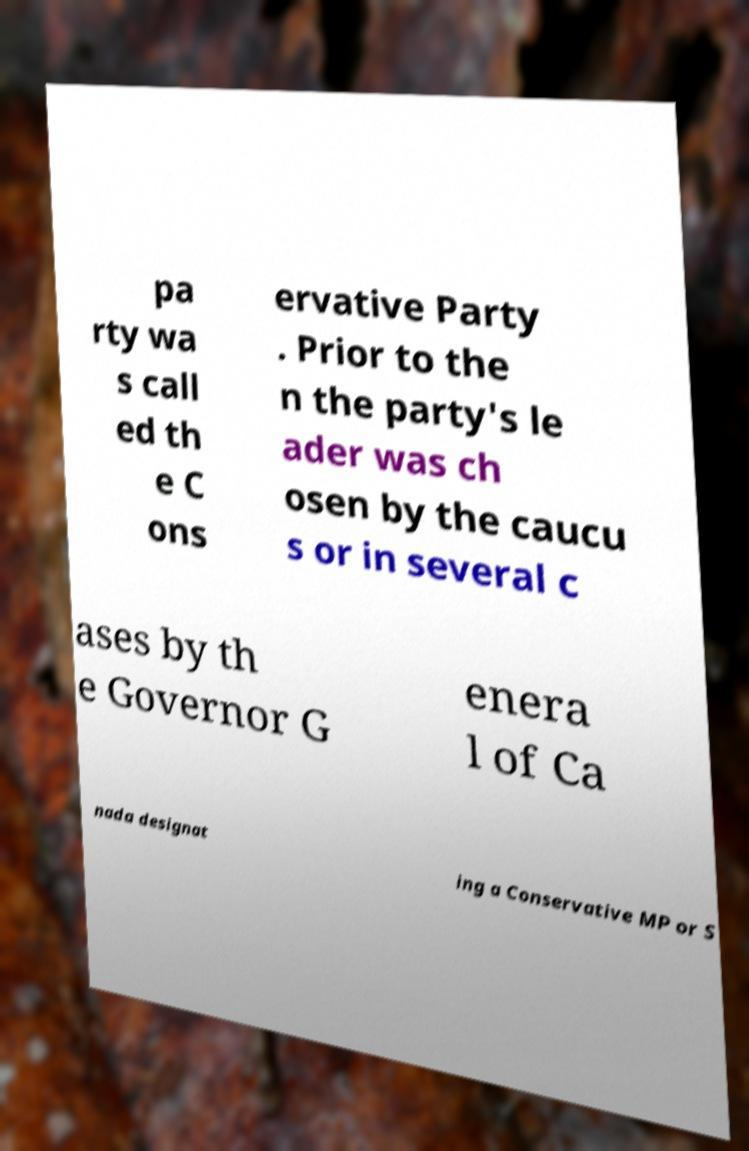Can you accurately transcribe the text from the provided image for me? pa rty wa s call ed th e C ons ervative Party . Prior to the n the party's le ader was ch osen by the caucu s or in several c ases by th e Governor G enera l of Ca nada designat ing a Conservative MP or S 